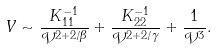<formula> <loc_0><loc_0><loc_500><loc_500>V \sim \frac { K ^ { - 1 } _ { 1 1 } } { \mathcal { V } ^ { 2 + 2 / \beta } } + \frac { K ^ { - 1 } _ { 2 2 } } { \mathcal { V } ^ { 2 + 2 / \gamma } } + \frac { 1 } { \mathcal { V } ^ { 3 } } .</formula> 